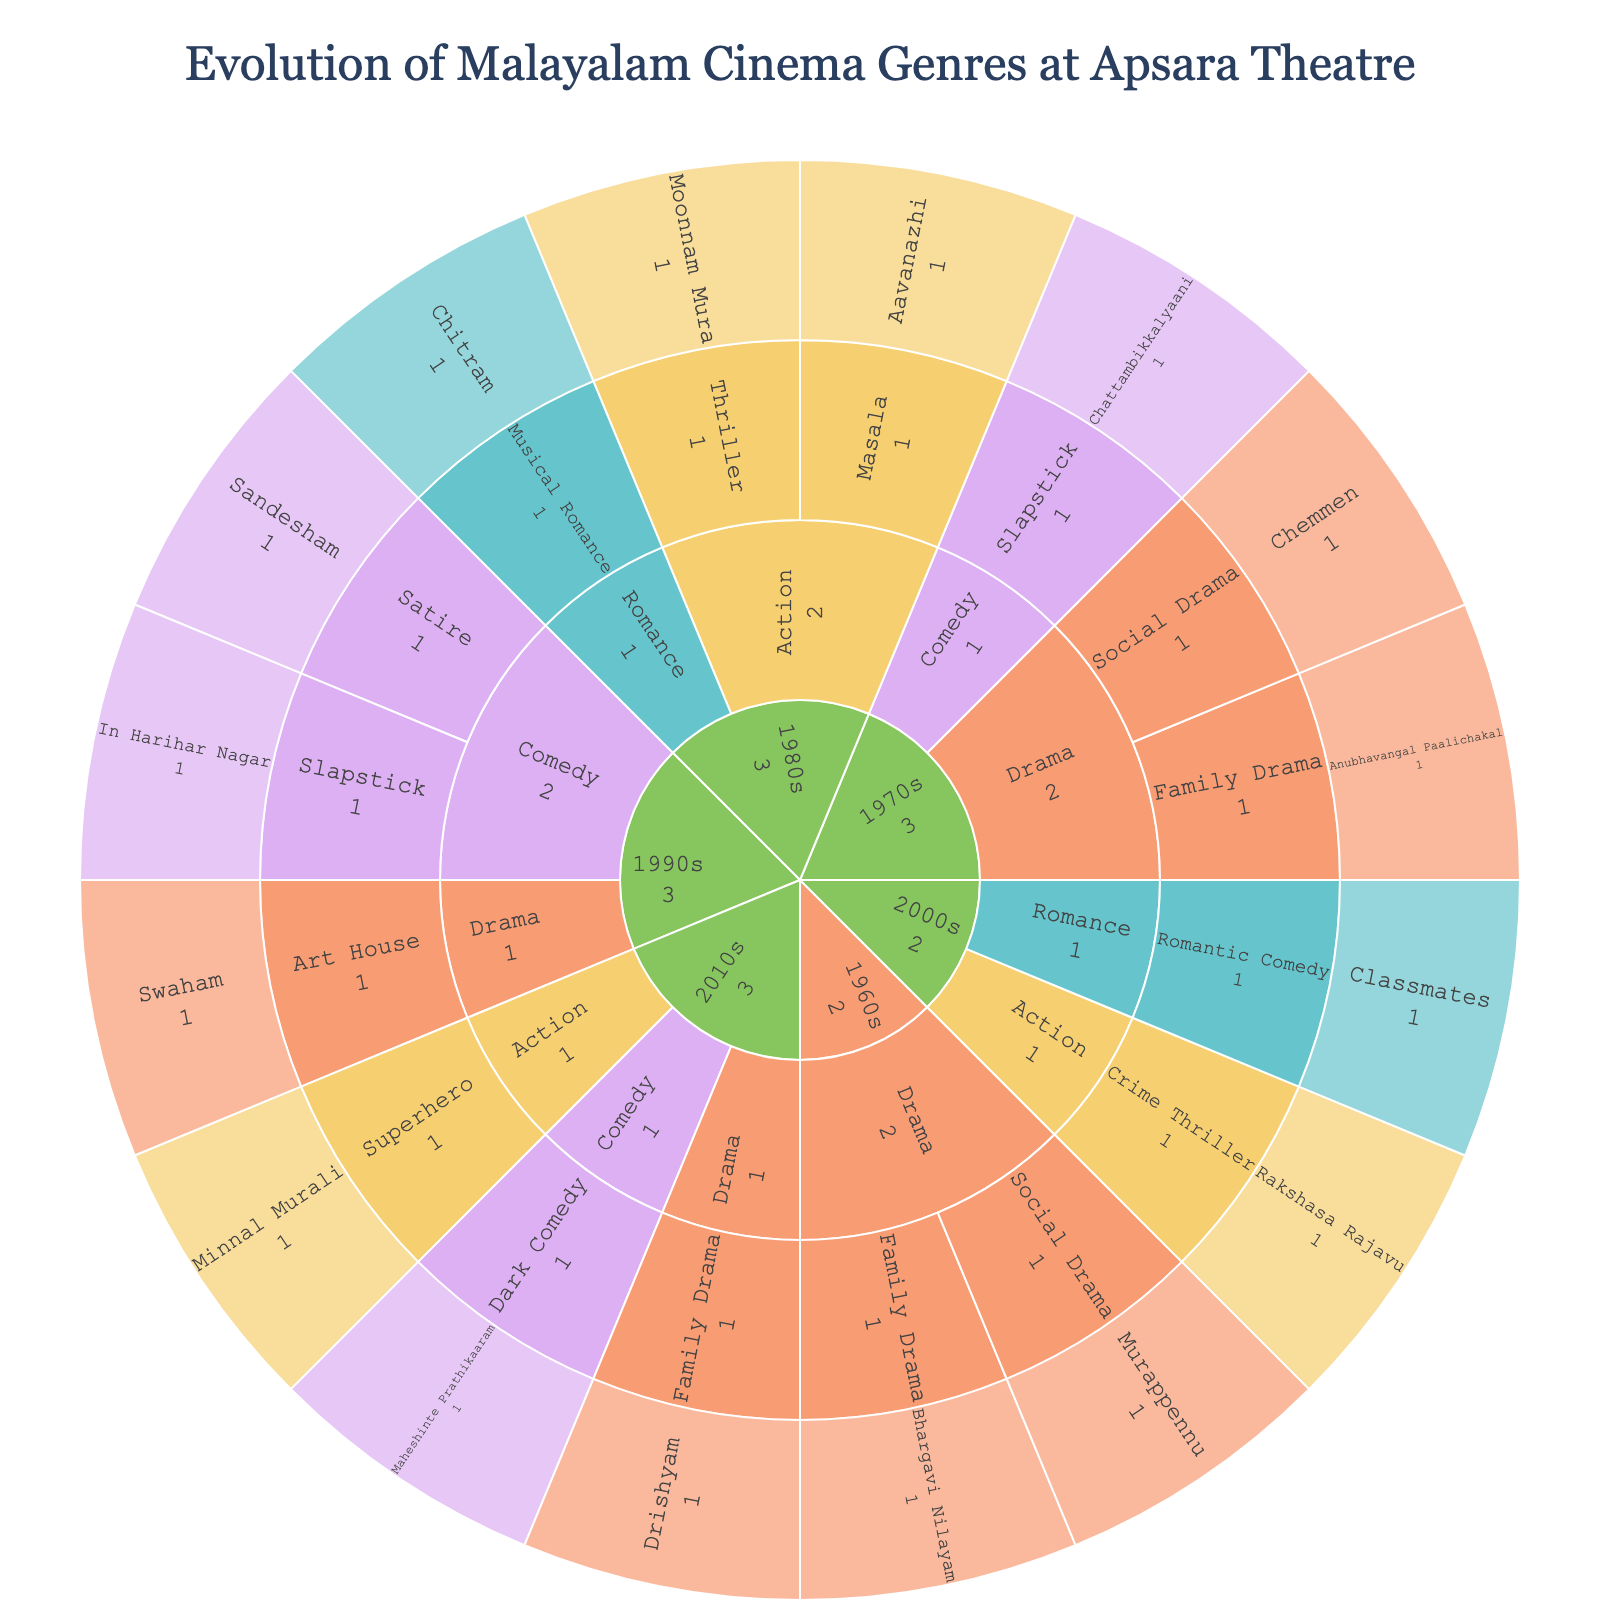What is the title of the plot? The title is usually located at the top of the plot. It summarizes the main idea which, for this plot, is probably about the progression of Malayalam cinema shown at Apsara Theatre.
Answer: Evolution of Malayalam Cinema Genres at Apsara Theatre Which genre has the most subgenres in the 1980s? By observing the 1980s branch of the sunburst plot, we can count the subgenres under each main genre. The genre with the most subgenres will have more branches.
Answer: Action Which decade featured the first Social Drama at Apsara Theatre? Look at the initial layers of the plot and locate the Family Drama subgenre within the Drama genre. Trace back to the decade it falls into.
Answer: 1960s How many genres are present in the 1970s? By examining the branches emerging from the 1970s section of the sunburst plot, we can count the individual genres.
Answer: 3 Which decade saw the introduction of the Superhero subgenre? Identify the Superhero subgenre in the sunburst plot and trace it back to its originating decade branch.
Answer: 2010s Which has more films, Family Drama or Social Drama in the 1960s? By comparing the number of films listed under the Family Drama and Social Drama subgenres in the 1960s, we can determine which has more films.
Answer: Equal Which genre had the fewest subgenres in the 2010s? By examining the branches of each genre in the 2010s, we can determine which genre has the least number of subgenres.
Answer: Comedy List all the films under the Action genre in the 1980s. Locate the Action genre within the 1980s decade and list the films under its subgenres.
Answer: Aavanazhi, Moonnam Mura How does the number of genres in the 1990s compare to the 2000s? Count the number of distinct genres in the 1990s and compare it to the count from the 2000s.
Answer: 3 in both What is the most frequent subgenre in the 1990s? Look at the 1990s decade and identify which subgenre appears the most by counting the number of appearances.
Answer: Comedy 